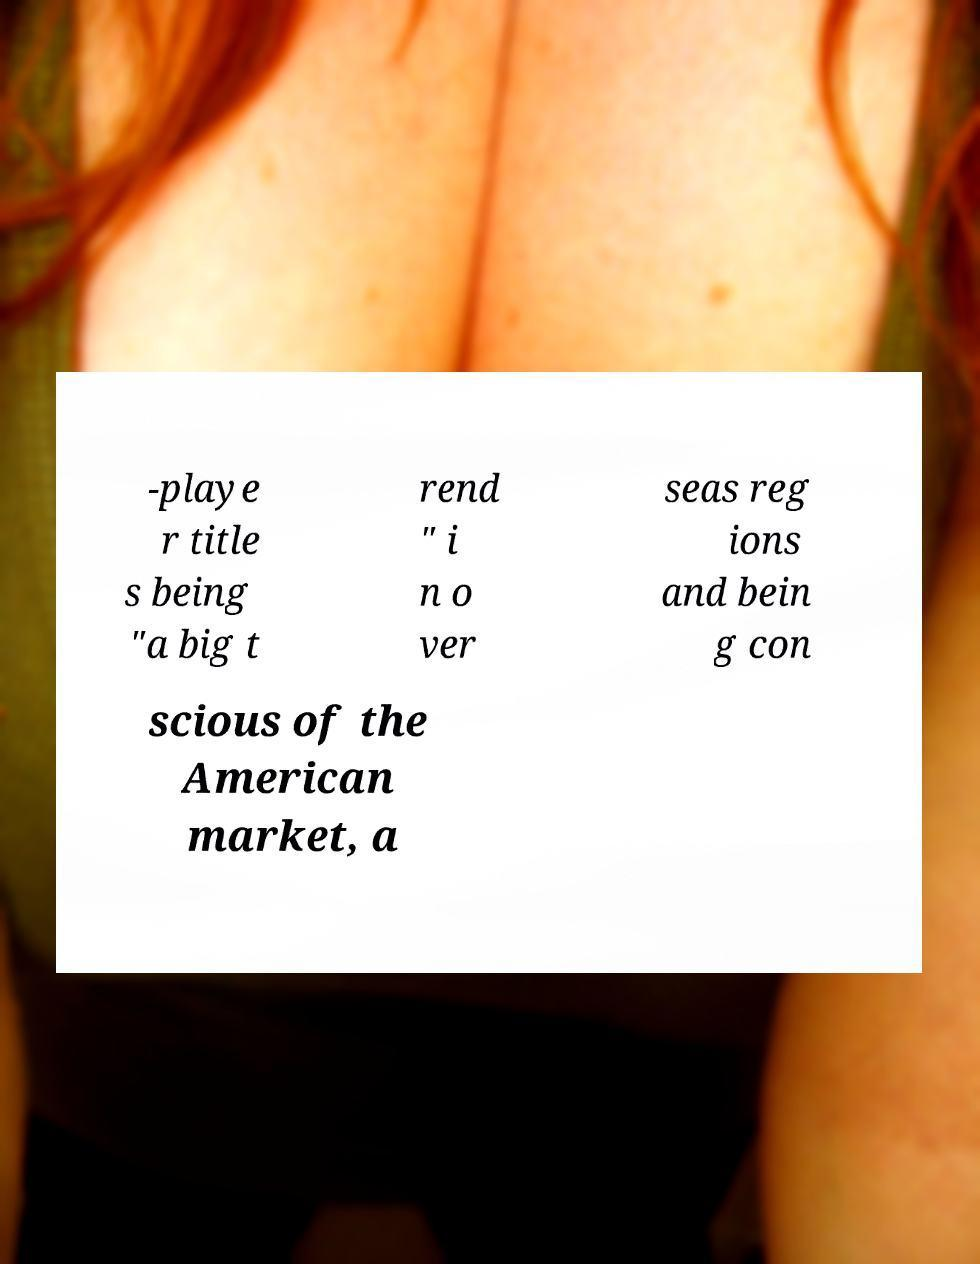For documentation purposes, I need the text within this image transcribed. Could you provide that? -playe r title s being "a big t rend " i n o ver seas reg ions and bein g con scious of the American market, a 